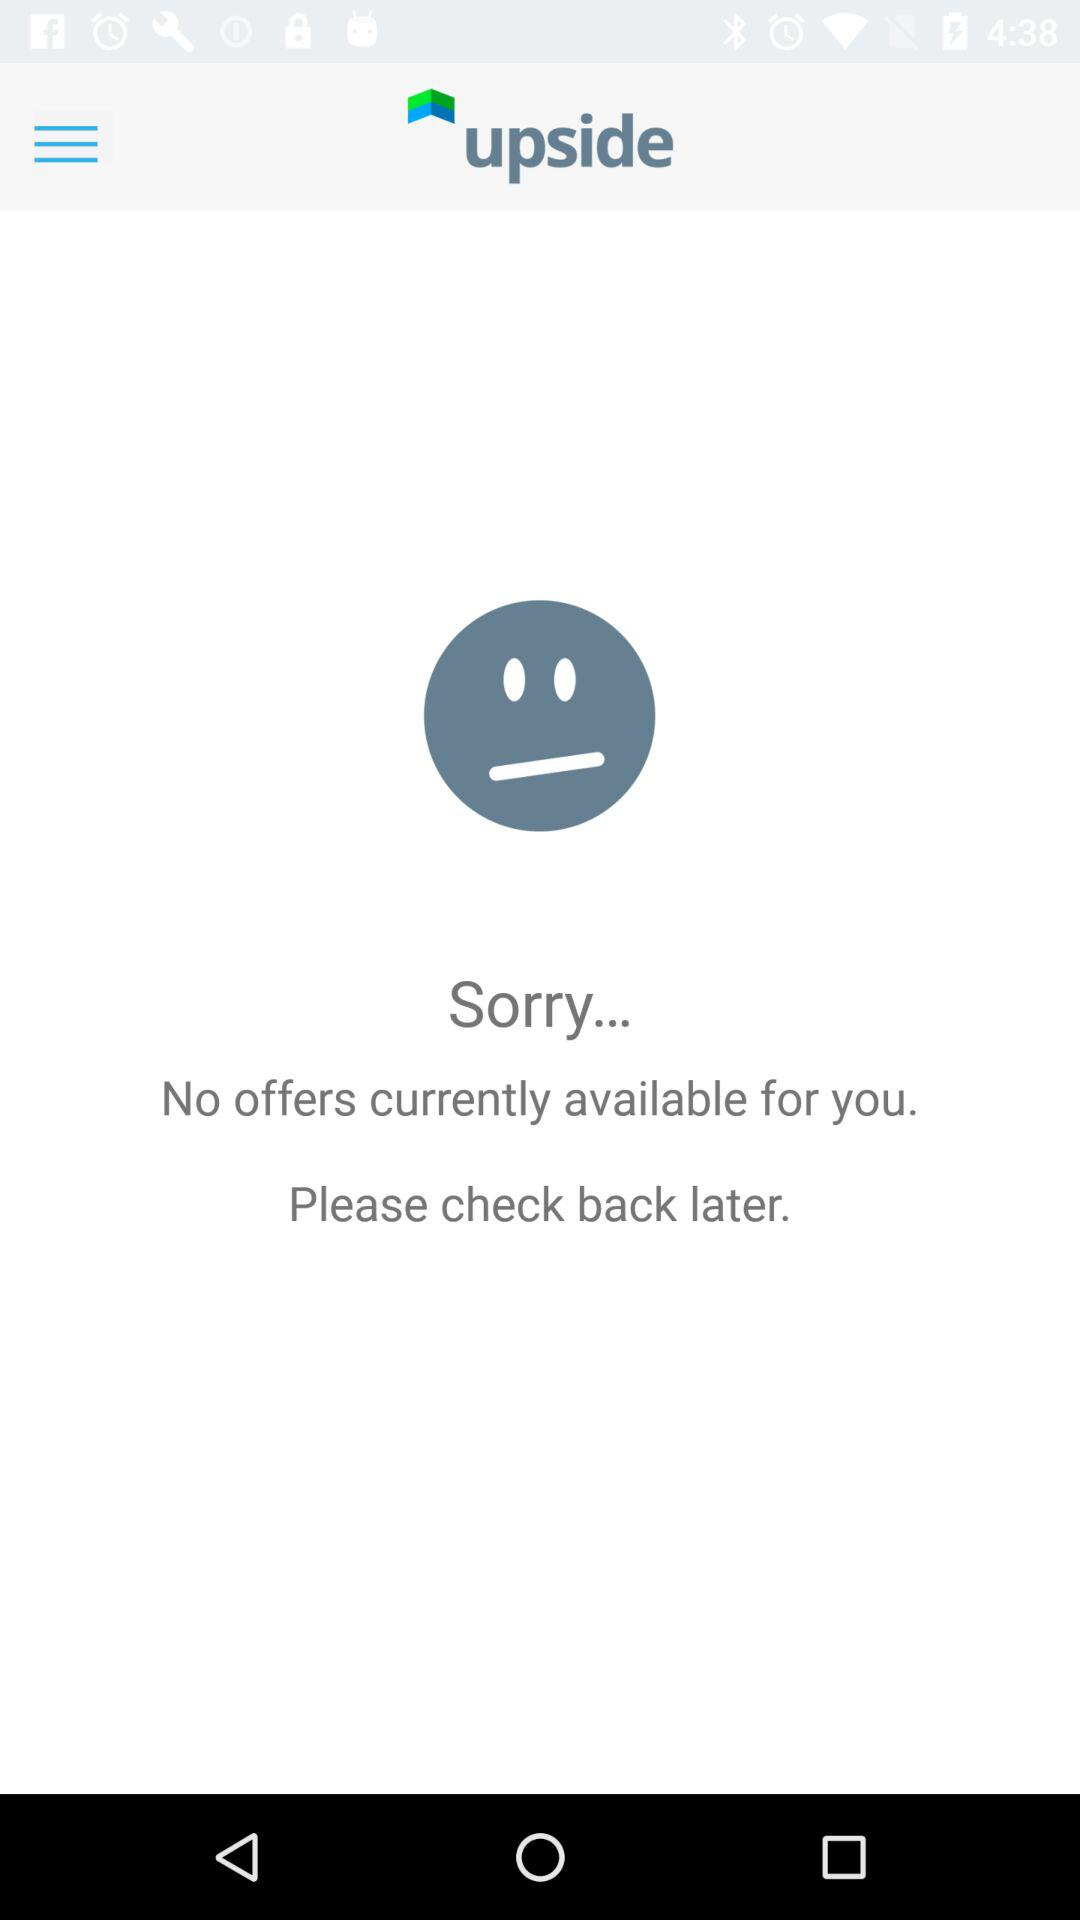Who developed "upside"?
When the provided information is insufficient, respond with <no answer>. <no answer> 